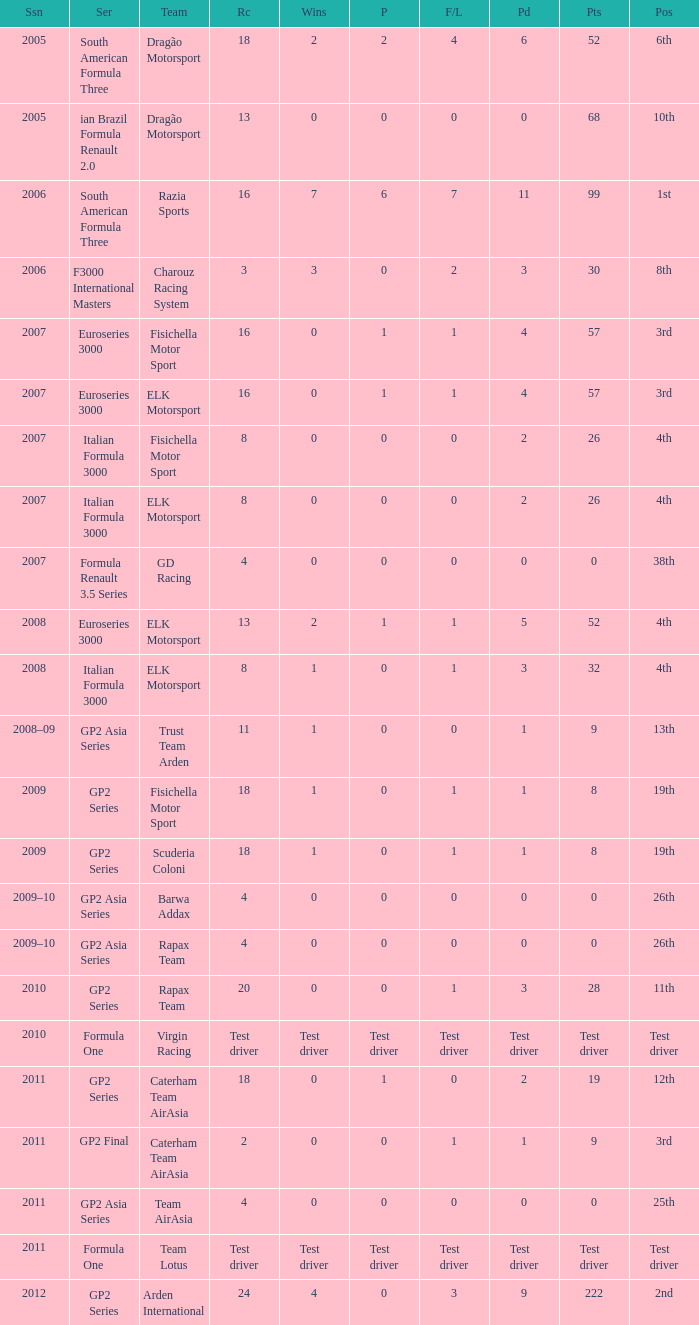What were the points in the year when his Wins were 0, his Podiums were 0, and he drove in 4 races? 0, 0, 0, 0. 